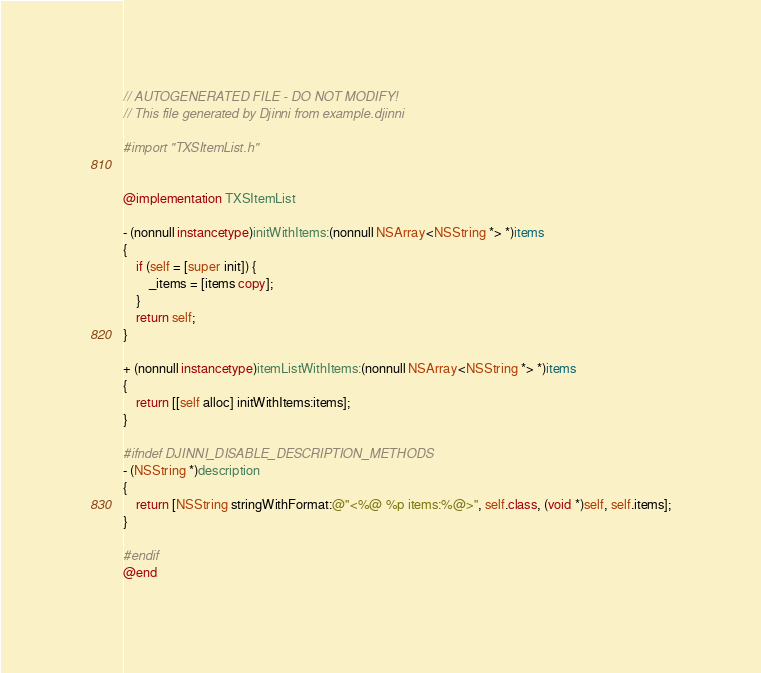<code> <loc_0><loc_0><loc_500><loc_500><_ObjectiveC_>// AUTOGENERATED FILE - DO NOT MODIFY!
// This file generated by Djinni from example.djinni

#import "TXSItemList.h"


@implementation TXSItemList

- (nonnull instancetype)initWithItems:(nonnull NSArray<NSString *> *)items
{
    if (self = [super init]) {
        _items = [items copy];
    }
    return self;
}

+ (nonnull instancetype)itemListWithItems:(nonnull NSArray<NSString *> *)items
{
    return [[self alloc] initWithItems:items];
}

#ifndef DJINNI_DISABLE_DESCRIPTION_METHODS
- (NSString *)description
{
    return [NSString stringWithFormat:@"<%@ %p items:%@>", self.class, (void *)self, self.items];
}

#endif
@end
</code> 